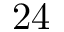Convert formula to latex. <formula><loc_0><loc_0><loc_500><loc_500>2 4</formula> 